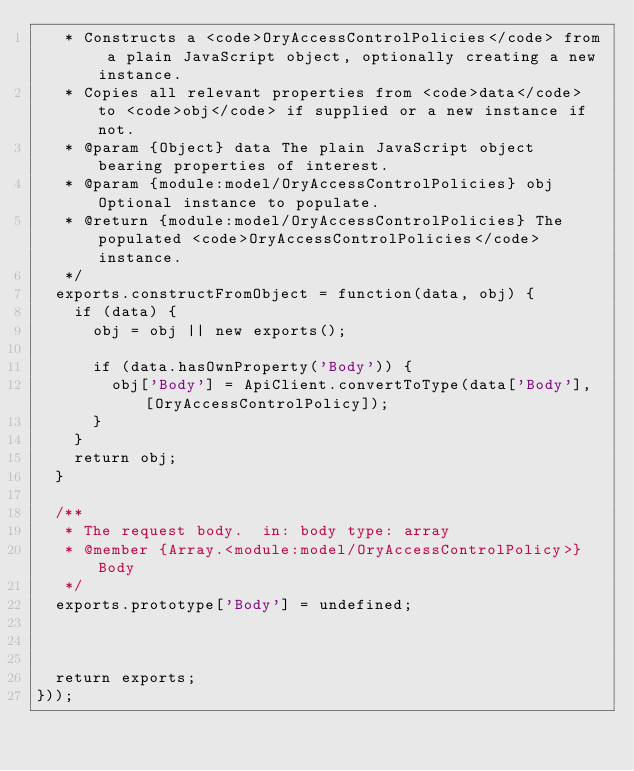Convert code to text. <code><loc_0><loc_0><loc_500><loc_500><_JavaScript_>   * Constructs a <code>OryAccessControlPolicies</code> from a plain JavaScript object, optionally creating a new instance.
   * Copies all relevant properties from <code>data</code> to <code>obj</code> if supplied or a new instance if not.
   * @param {Object} data The plain JavaScript object bearing properties of interest.
   * @param {module:model/OryAccessControlPolicies} obj Optional instance to populate.
   * @return {module:model/OryAccessControlPolicies} The populated <code>OryAccessControlPolicies</code> instance.
   */
  exports.constructFromObject = function(data, obj) {
    if (data) {
      obj = obj || new exports();

      if (data.hasOwnProperty('Body')) {
        obj['Body'] = ApiClient.convertToType(data['Body'], [OryAccessControlPolicy]);
      }
    }
    return obj;
  }

  /**
   * The request body.  in: body type: array
   * @member {Array.<module:model/OryAccessControlPolicy>} Body
   */
  exports.prototype['Body'] = undefined;



  return exports;
}));


</code> 